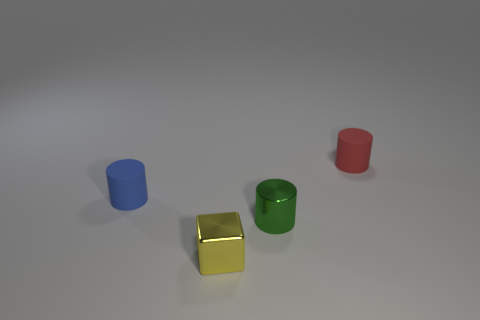There is a rubber cylinder in front of the tiny red matte thing; does it have the same color as the small cube?
Offer a very short reply. No. How many cylinders are tiny objects or tiny blue objects?
Give a very brief answer. 3. What shape is the tiny matte object left of the small metal object that is to the right of the small yellow metal block?
Offer a very short reply. Cylinder. There is a yellow shiny cube that is right of the rubber cylinder in front of the small matte object behind the tiny blue matte cylinder; what size is it?
Offer a terse response. Small. Do the red rubber object and the block have the same size?
Your response must be concise. Yes. What number of objects are either tiny brown metallic balls or matte cylinders?
Your answer should be compact. 2. There is a matte object that is to the left of the tiny rubber cylinder that is to the right of the small green shiny cylinder; what is its size?
Make the answer very short. Small. What is the size of the shiny cylinder?
Your response must be concise. Small. There is a object that is both behind the small green object and to the right of the yellow shiny block; what is its shape?
Keep it short and to the point. Cylinder. There is a metallic thing that is the same shape as the blue matte object; what color is it?
Keep it short and to the point. Green. 